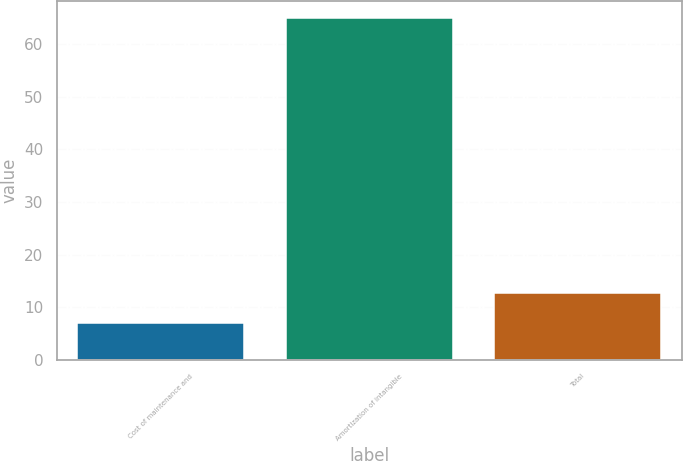Convert chart. <chart><loc_0><loc_0><loc_500><loc_500><bar_chart><fcel>Cost of maintenance and<fcel>Amortization of intangible<fcel>Total<nl><fcel>7<fcel>65<fcel>12.8<nl></chart> 